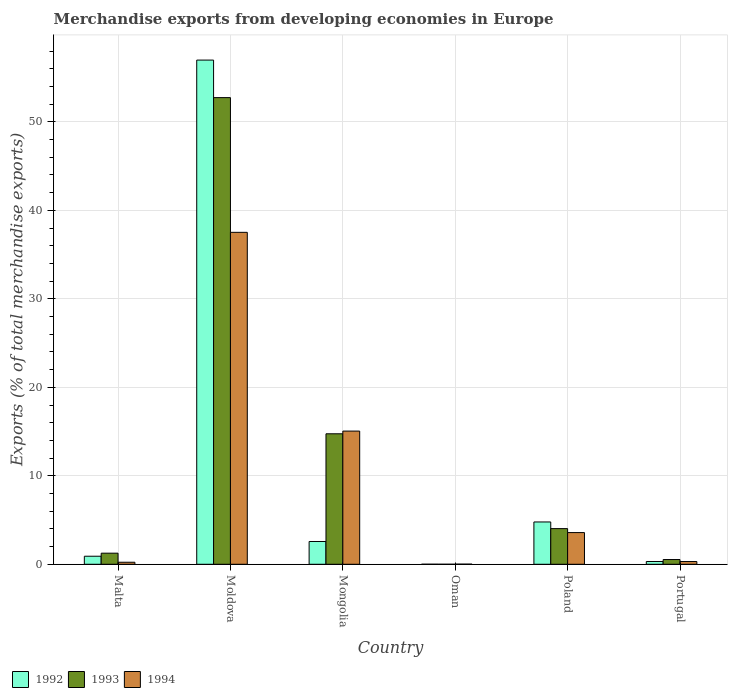How many different coloured bars are there?
Your answer should be compact. 3. How many groups of bars are there?
Provide a succinct answer. 6. How many bars are there on the 2nd tick from the left?
Provide a short and direct response. 3. What is the label of the 4th group of bars from the left?
Your response must be concise. Oman. In how many cases, is the number of bars for a given country not equal to the number of legend labels?
Provide a short and direct response. 0. What is the percentage of total merchandise exports in 1994 in Malta?
Keep it short and to the point. 0.23. Across all countries, what is the maximum percentage of total merchandise exports in 1992?
Give a very brief answer. 56.98. Across all countries, what is the minimum percentage of total merchandise exports in 1994?
Your answer should be very brief. 0.01. In which country was the percentage of total merchandise exports in 1992 maximum?
Your answer should be compact. Moldova. In which country was the percentage of total merchandise exports in 1993 minimum?
Your answer should be very brief. Oman. What is the total percentage of total merchandise exports in 1994 in the graph?
Your answer should be very brief. 56.7. What is the difference between the percentage of total merchandise exports in 1994 in Malta and that in Poland?
Your answer should be very brief. -3.35. What is the difference between the percentage of total merchandise exports in 1992 in Poland and the percentage of total merchandise exports in 1994 in Mongolia?
Make the answer very short. -10.27. What is the average percentage of total merchandise exports in 1993 per country?
Your answer should be very brief. 12.22. What is the difference between the percentage of total merchandise exports of/in 1993 and percentage of total merchandise exports of/in 1994 in Moldova?
Your answer should be compact. 15.22. What is the ratio of the percentage of total merchandise exports in 1994 in Malta to that in Moldova?
Ensure brevity in your answer.  0.01. Is the percentage of total merchandise exports in 1994 in Moldova less than that in Poland?
Provide a succinct answer. No. Is the difference between the percentage of total merchandise exports in 1993 in Malta and Moldova greater than the difference between the percentage of total merchandise exports in 1994 in Malta and Moldova?
Your answer should be very brief. No. What is the difference between the highest and the second highest percentage of total merchandise exports in 1994?
Your answer should be compact. -33.93. What is the difference between the highest and the lowest percentage of total merchandise exports in 1992?
Offer a very short reply. 56.97. In how many countries, is the percentage of total merchandise exports in 1993 greater than the average percentage of total merchandise exports in 1993 taken over all countries?
Make the answer very short. 2. Is the sum of the percentage of total merchandise exports in 1994 in Moldova and Poland greater than the maximum percentage of total merchandise exports in 1992 across all countries?
Provide a succinct answer. No. What does the 2nd bar from the left in Malta represents?
Provide a short and direct response. 1993. What does the 2nd bar from the right in Moldova represents?
Make the answer very short. 1993. How many bars are there?
Your answer should be compact. 18. Are all the bars in the graph horizontal?
Keep it short and to the point. No. How many countries are there in the graph?
Make the answer very short. 6. What is the difference between two consecutive major ticks on the Y-axis?
Offer a very short reply. 10. Does the graph contain grids?
Give a very brief answer. Yes. Where does the legend appear in the graph?
Make the answer very short. Bottom left. What is the title of the graph?
Your response must be concise. Merchandise exports from developing economies in Europe. What is the label or title of the X-axis?
Provide a short and direct response. Country. What is the label or title of the Y-axis?
Your answer should be very brief. Exports (% of total merchandise exports). What is the Exports (% of total merchandise exports) of 1992 in Malta?
Your response must be concise. 0.91. What is the Exports (% of total merchandise exports) of 1993 in Malta?
Your response must be concise. 1.26. What is the Exports (% of total merchandise exports) of 1994 in Malta?
Your answer should be very brief. 0.23. What is the Exports (% of total merchandise exports) in 1992 in Moldova?
Your answer should be very brief. 56.98. What is the Exports (% of total merchandise exports) of 1993 in Moldova?
Your response must be concise. 52.74. What is the Exports (% of total merchandise exports) of 1994 in Moldova?
Provide a succinct answer. 37.51. What is the Exports (% of total merchandise exports) in 1992 in Mongolia?
Ensure brevity in your answer.  2.57. What is the Exports (% of total merchandise exports) in 1993 in Mongolia?
Offer a very short reply. 14.75. What is the Exports (% of total merchandise exports) in 1994 in Mongolia?
Provide a succinct answer. 15.05. What is the Exports (% of total merchandise exports) of 1992 in Oman?
Your answer should be very brief. 0. What is the Exports (% of total merchandise exports) in 1993 in Oman?
Offer a terse response. 0. What is the Exports (% of total merchandise exports) in 1994 in Oman?
Your answer should be compact. 0.01. What is the Exports (% of total merchandise exports) of 1992 in Poland?
Ensure brevity in your answer.  4.78. What is the Exports (% of total merchandise exports) in 1993 in Poland?
Your answer should be compact. 4.03. What is the Exports (% of total merchandise exports) in 1994 in Poland?
Provide a succinct answer. 3.58. What is the Exports (% of total merchandise exports) in 1992 in Portugal?
Give a very brief answer. 0.32. What is the Exports (% of total merchandise exports) in 1993 in Portugal?
Offer a terse response. 0.54. What is the Exports (% of total merchandise exports) in 1994 in Portugal?
Provide a succinct answer. 0.31. Across all countries, what is the maximum Exports (% of total merchandise exports) in 1992?
Offer a terse response. 56.98. Across all countries, what is the maximum Exports (% of total merchandise exports) in 1993?
Make the answer very short. 52.74. Across all countries, what is the maximum Exports (% of total merchandise exports) of 1994?
Your answer should be very brief. 37.51. Across all countries, what is the minimum Exports (% of total merchandise exports) of 1992?
Offer a very short reply. 0. Across all countries, what is the minimum Exports (% of total merchandise exports) in 1993?
Provide a succinct answer. 0. Across all countries, what is the minimum Exports (% of total merchandise exports) in 1994?
Provide a short and direct response. 0.01. What is the total Exports (% of total merchandise exports) of 1992 in the graph?
Your answer should be compact. 65.56. What is the total Exports (% of total merchandise exports) of 1993 in the graph?
Provide a short and direct response. 73.31. What is the total Exports (% of total merchandise exports) in 1994 in the graph?
Offer a terse response. 56.7. What is the difference between the Exports (% of total merchandise exports) in 1992 in Malta and that in Moldova?
Your response must be concise. -56.07. What is the difference between the Exports (% of total merchandise exports) in 1993 in Malta and that in Moldova?
Ensure brevity in your answer.  -51.48. What is the difference between the Exports (% of total merchandise exports) in 1994 in Malta and that in Moldova?
Give a very brief answer. -37.28. What is the difference between the Exports (% of total merchandise exports) in 1992 in Malta and that in Mongolia?
Provide a succinct answer. -1.66. What is the difference between the Exports (% of total merchandise exports) in 1993 in Malta and that in Mongolia?
Ensure brevity in your answer.  -13.49. What is the difference between the Exports (% of total merchandise exports) in 1994 in Malta and that in Mongolia?
Your response must be concise. -14.82. What is the difference between the Exports (% of total merchandise exports) in 1992 in Malta and that in Oman?
Offer a terse response. 0.91. What is the difference between the Exports (% of total merchandise exports) of 1993 in Malta and that in Oman?
Offer a terse response. 1.25. What is the difference between the Exports (% of total merchandise exports) in 1994 in Malta and that in Oman?
Give a very brief answer. 0.22. What is the difference between the Exports (% of total merchandise exports) in 1992 in Malta and that in Poland?
Your answer should be compact. -3.87. What is the difference between the Exports (% of total merchandise exports) in 1993 in Malta and that in Poland?
Make the answer very short. -2.78. What is the difference between the Exports (% of total merchandise exports) in 1994 in Malta and that in Poland?
Make the answer very short. -3.35. What is the difference between the Exports (% of total merchandise exports) in 1992 in Malta and that in Portugal?
Make the answer very short. 0.6. What is the difference between the Exports (% of total merchandise exports) in 1993 in Malta and that in Portugal?
Your answer should be compact. 0.72. What is the difference between the Exports (% of total merchandise exports) of 1994 in Malta and that in Portugal?
Keep it short and to the point. -0.08. What is the difference between the Exports (% of total merchandise exports) of 1992 in Moldova and that in Mongolia?
Keep it short and to the point. 54.4. What is the difference between the Exports (% of total merchandise exports) of 1993 in Moldova and that in Mongolia?
Make the answer very short. 37.99. What is the difference between the Exports (% of total merchandise exports) of 1994 in Moldova and that in Mongolia?
Ensure brevity in your answer.  22.46. What is the difference between the Exports (% of total merchandise exports) in 1992 in Moldova and that in Oman?
Provide a short and direct response. 56.97. What is the difference between the Exports (% of total merchandise exports) of 1993 in Moldova and that in Oman?
Make the answer very short. 52.74. What is the difference between the Exports (% of total merchandise exports) in 1994 in Moldova and that in Oman?
Keep it short and to the point. 37.5. What is the difference between the Exports (% of total merchandise exports) of 1992 in Moldova and that in Poland?
Give a very brief answer. 52.2. What is the difference between the Exports (% of total merchandise exports) of 1993 in Moldova and that in Poland?
Give a very brief answer. 48.71. What is the difference between the Exports (% of total merchandise exports) of 1994 in Moldova and that in Poland?
Your response must be concise. 33.93. What is the difference between the Exports (% of total merchandise exports) of 1992 in Moldova and that in Portugal?
Offer a terse response. 56.66. What is the difference between the Exports (% of total merchandise exports) of 1993 in Moldova and that in Portugal?
Provide a succinct answer. 52.2. What is the difference between the Exports (% of total merchandise exports) of 1994 in Moldova and that in Portugal?
Give a very brief answer. 37.2. What is the difference between the Exports (% of total merchandise exports) in 1992 in Mongolia and that in Oman?
Your response must be concise. 2.57. What is the difference between the Exports (% of total merchandise exports) of 1993 in Mongolia and that in Oman?
Offer a very short reply. 14.75. What is the difference between the Exports (% of total merchandise exports) of 1994 in Mongolia and that in Oman?
Offer a terse response. 15.04. What is the difference between the Exports (% of total merchandise exports) of 1992 in Mongolia and that in Poland?
Provide a short and direct response. -2.21. What is the difference between the Exports (% of total merchandise exports) in 1993 in Mongolia and that in Poland?
Offer a very short reply. 10.72. What is the difference between the Exports (% of total merchandise exports) of 1994 in Mongolia and that in Poland?
Offer a terse response. 11.47. What is the difference between the Exports (% of total merchandise exports) of 1992 in Mongolia and that in Portugal?
Give a very brief answer. 2.26. What is the difference between the Exports (% of total merchandise exports) in 1993 in Mongolia and that in Portugal?
Provide a succinct answer. 14.21. What is the difference between the Exports (% of total merchandise exports) of 1994 in Mongolia and that in Portugal?
Offer a very short reply. 14.74. What is the difference between the Exports (% of total merchandise exports) of 1992 in Oman and that in Poland?
Offer a very short reply. -4.78. What is the difference between the Exports (% of total merchandise exports) of 1993 in Oman and that in Poland?
Offer a very short reply. -4.03. What is the difference between the Exports (% of total merchandise exports) in 1994 in Oman and that in Poland?
Your response must be concise. -3.57. What is the difference between the Exports (% of total merchandise exports) in 1992 in Oman and that in Portugal?
Ensure brevity in your answer.  -0.31. What is the difference between the Exports (% of total merchandise exports) of 1993 in Oman and that in Portugal?
Offer a terse response. -0.53. What is the difference between the Exports (% of total merchandise exports) of 1994 in Oman and that in Portugal?
Your answer should be very brief. -0.29. What is the difference between the Exports (% of total merchandise exports) of 1992 in Poland and that in Portugal?
Provide a short and direct response. 4.47. What is the difference between the Exports (% of total merchandise exports) in 1993 in Poland and that in Portugal?
Provide a short and direct response. 3.49. What is the difference between the Exports (% of total merchandise exports) in 1994 in Poland and that in Portugal?
Ensure brevity in your answer.  3.27. What is the difference between the Exports (% of total merchandise exports) in 1992 in Malta and the Exports (% of total merchandise exports) in 1993 in Moldova?
Provide a short and direct response. -51.83. What is the difference between the Exports (% of total merchandise exports) in 1992 in Malta and the Exports (% of total merchandise exports) in 1994 in Moldova?
Provide a succinct answer. -36.6. What is the difference between the Exports (% of total merchandise exports) of 1993 in Malta and the Exports (% of total merchandise exports) of 1994 in Moldova?
Give a very brief answer. -36.26. What is the difference between the Exports (% of total merchandise exports) in 1992 in Malta and the Exports (% of total merchandise exports) in 1993 in Mongolia?
Keep it short and to the point. -13.84. What is the difference between the Exports (% of total merchandise exports) in 1992 in Malta and the Exports (% of total merchandise exports) in 1994 in Mongolia?
Your answer should be compact. -14.14. What is the difference between the Exports (% of total merchandise exports) of 1993 in Malta and the Exports (% of total merchandise exports) of 1994 in Mongolia?
Ensure brevity in your answer.  -13.8. What is the difference between the Exports (% of total merchandise exports) of 1992 in Malta and the Exports (% of total merchandise exports) of 1993 in Oman?
Give a very brief answer. 0.91. What is the difference between the Exports (% of total merchandise exports) of 1992 in Malta and the Exports (% of total merchandise exports) of 1994 in Oman?
Make the answer very short. 0.9. What is the difference between the Exports (% of total merchandise exports) in 1993 in Malta and the Exports (% of total merchandise exports) in 1994 in Oman?
Your response must be concise. 1.24. What is the difference between the Exports (% of total merchandise exports) in 1992 in Malta and the Exports (% of total merchandise exports) in 1993 in Poland?
Give a very brief answer. -3.12. What is the difference between the Exports (% of total merchandise exports) of 1992 in Malta and the Exports (% of total merchandise exports) of 1994 in Poland?
Ensure brevity in your answer.  -2.67. What is the difference between the Exports (% of total merchandise exports) of 1993 in Malta and the Exports (% of total merchandise exports) of 1994 in Poland?
Your answer should be very brief. -2.33. What is the difference between the Exports (% of total merchandise exports) of 1992 in Malta and the Exports (% of total merchandise exports) of 1993 in Portugal?
Provide a succinct answer. 0.37. What is the difference between the Exports (% of total merchandise exports) of 1992 in Malta and the Exports (% of total merchandise exports) of 1994 in Portugal?
Offer a terse response. 0.6. What is the difference between the Exports (% of total merchandise exports) in 1993 in Malta and the Exports (% of total merchandise exports) in 1994 in Portugal?
Offer a very short reply. 0.95. What is the difference between the Exports (% of total merchandise exports) in 1992 in Moldova and the Exports (% of total merchandise exports) in 1993 in Mongolia?
Offer a terse response. 42.23. What is the difference between the Exports (% of total merchandise exports) in 1992 in Moldova and the Exports (% of total merchandise exports) in 1994 in Mongolia?
Give a very brief answer. 41.93. What is the difference between the Exports (% of total merchandise exports) in 1993 in Moldova and the Exports (% of total merchandise exports) in 1994 in Mongolia?
Give a very brief answer. 37.69. What is the difference between the Exports (% of total merchandise exports) in 1992 in Moldova and the Exports (% of total merchandise exports) in 1993 in Oman?
Keep it short and to the point. 56.98. What is the difference between the Exports (% of total merchandise exports) of 1992 in Moldova and the Exports (% of total merchandise exports) of 1994 in Oman?
Your response must be concise. 56.96. What is the difference between the Exports (% of total merchandise exports) in 1993 in Moldova and the Exports (% of total merchandise exports) in 1994 in Oman?
Offer a very short reply. 52.72. What is the difference between the Exports (% of total merchandise exports) of 1992 in Moldova and the Exports (% of total merchandise exports) of 1993 in Poland?
Your answer should be compact. 52.95. What is the difference between the Exports (% of total merchandise exports) in 1992 in Moldova and the Exports (% of total merchandise exports) in 1994 in Poland?
Ensure brevity in your answer.  53.4. What is the difference between the Exports (% of total merchandise exports) of 1993 in Moldova and the Exports (% of total merchandise exports) of 1994 in Poland?
Your response must be concise. 49.15. What is the difference between the Exports (% of total merchandise exports) of 1992 in Moldova and the Exports (% of total merchandise exports) of 1993 in Portugal?
Make the answer very short. 56.44. What is the difference between the Exports (% of total merchandise exports) in 1992 in Moldova and the Exports (% of total merchandise exports) in 1994 in Portugal?
Your answer should be compact. 56.67. What is the difference between the Exports (% of total merchandise exports) of 1993 in Moldova and the Exports (% of total merchandise exports) of 1994 in Portugal?
Offer a terse response. 52.43. What is the difference between the Exports (% of total merchandise exports) in 1992 in Mongolia and the Exports (% of total merchandise exports) in 1993 in Oman?
Give a very brief answer. 2.57. What is the difference between the Exports (% of total merchandise exports) of 1992 in Mongolia and the Exports (% of total merchandise exports) of 1994 in Oman?
Make the answer very short. 2.56. What is the difference between the Exports (% of total merchandise exports) in 1993 in Mongolia and the Exports (% of total merchandise exports) in 1994 in Oman?
Provide a short and direct response. 14.73. What is the difference between the Exports (% of total merchandise exports) in 1992 in Mongolia and the Exports (% of total merchandise exports) in 1993 in Poland?
Give a very brief answer. -1.46. What is the difference between the Exports (% of total merchandise exports) in 1992 in Mongolia and the Exports (% of total merchandise exports) in 1994 in Poland?
Offer a very short reply. -1.01. What is the difference between the Exports (% of total merchandise exports) in 1993 in Mongolia and the Exports (% of total merchandise exports) in 1994 in Poland?
Make the answer very short. 11.16. What is the difference between the Exports (% of total merchandise exports) in 1992 in Mongolia and the Exports (% of total merchandise exports) in 1993 in Portugal?
Provide a short and direct response. 2.04. What is the difference between the Exports (% of total merchandise exports) of 1992 in Mongolia and the Exports (% of total merchandise exports) of 1994 in Portugal?
Ensure brevity in your answer.  2.27. What is the difference between the Exports (% of total merchandise exports) in 1993 in Mongolia and the Exports (% of total merchandise exports) in 1994 in Portugal?
Offer a very short reply. 14.44. What is the difference between the Exports (% of total merchandise exports) of 1992 in Oman and the Exports (% of total merchandise exports) of 1993 in Poland?
Your answer should be very brief. -4.03. What is the difference between the Exports (% of total merchandise exports) in 1992 in Oman and the Exports (% of total merchandise exports) in 1994 in Poland?
Give a very brief answer. -3.58. What is the difference between the Exports (% of total merchandise exports) of 1993 in Oman and the Exports (% of total merchandise exports) of 1994 in Poland?
Your answer should be compact. -3.58. What is the difference between the Exports (% of total merchandise exports) in 1992 in Oman and the Exports (% of total merchandise exports) in 1993 in Portugal?
Give a very brief answer. -0.53. What is the difference between the Exports (% of total merchandise exports) of 1992 in Oman and the Exports (% of total merchandise exports) of 1994 in Portugal?
Provide a short and direct response. -0.3. What is the difference between the Exports (% of total merchandise exports) of 1993 in Oman and the Exports (% of total merchandise exports) of 1994 in Portugal?
Keep it short and to the point. -0.31. What is the difference between the Exports (% of total merchandise exports) in 1992 in Poland and the Exports (% of total merchandise exports) in 1993 in Portugal?
Offer a very short reply. 4.25. What is the difference between the Exports (% of total merchandise exports) of 1992 in Poland and the Exports (% of total merchandise exports) of 1994 in Portugal?
Provide a succinct answer. 4.47. What is the difference between the Exports (% of total merchandise exports) of 1993 in Poland and the Exports (% of total merchandise exports) of 1994 in Portugal?
Provide a succinct answer. 3.72. What is the average Exports (% of total merchandise exports) of 1992 per country?
Make the answer very short. 10.93. What is the average Exports (% of total merchandise exports) of 1993 per country?
Your answer should be compact. 12.22. What is the average Exports (% of total merchandise exports) in 1994 per country?
Keep it short and to the point. 9.45. What is the difference between the Exports (% of total merchandise exports) of 1992 and Exports (% of total merchandise exports) of 1993 in Malta?
Your answer should be very brief. -0.34. What is the difference between the Exports (% of total merchandise exports) of 1992 and Exports (% of total merchandise exports) of 1994 in Malta?
Keep it short and to the point. 0.68. What is the difference between the Exports (% of total merchandise exports) in 1993 and Exports (% of total merchandise exports) in 1994 in Malta?
Your answer should be very brief. 1.03. What is the difference between the Exports (% of total merchandise exports) of 1992 and Exports (% of total merchandise exports) of 1993 in Moldova?
Give a very brief answer. 4.24. What is the difference between the Exports (% of total merchandise exports) in 1992 and Exports (% of total merchandise exports) in 1994 in Moldova?
Provide a succinct answer. 19.47. What is the difference between the Exports (% of total merchandise exports) in 1993 and Exports (% of total merchandise exports) in 1994 in Moldova?
Provide a succinct answer. 15.22. What is the difference between the Exports (% of total merchandise exports) in 1992 and Exports (% of total merchandise exports) in 1993 in Mongolia?
Provide a short and direct response. -12.17. What is the difference between the Exports (% of total merchandise exports) of 1992 and Exports (% of total merchandise exports) of 1994 in Mongolia?
Provide a short and direct response. -12.48. What is the difference between the Exports (% of total merchandise exports) of 1993 and Exports (% of total merchandise exports) of 1994 in Mongolia?
Give a very brief answer. -0.31. What is the difference between the Exports (% of total merchandise exports) in 1992 and Exports (% of total merchandise exports) in 1993 in Oman?
Provide a short and direct response. 0. What is the difference between the Exports (% of total merchandise exports) in 1992 and Exports (% of total merchandise exports) in 1994 in Oman?
Your answer should be very brief. -0.01. What is the difference between the Exports (% of total merchandise exports) in 1993 and Exports (% of total merchandise exports) in 1994 in Oman?
Ensure brevity in your answer.  -0.01. What is the difference between the Exports (% of total merchandise exports) in 1992 and Exports (% of total merchandise exports) in 1993 in Poland?
Your answer should be very brief. 0.75. What is the difference between the Exports (% of total merchandise exports) in 1992 and Exports (% of total merchandise exports) in 1994 in Poland?
Your response must be concise. 1.2. What is the difference between the Exports (% of total merchandise exports) in 1993 and Exports (% of total merchandise exports) in 1994 in Poland?
Your answer should be compact. 0.45. What is the difference between the Exports (% of total merchandise exports) of 1992 and Exports (% of total merchandise exports) of 1993 in Portugal?
Your answer should be very brief. -0.22. What is the difference between the Exports (% of total merchandise exports) of 1992 and Exports (% of total merchandise exports) of 1994 in Portugal?
Make the answer very short. 0.01. What is the difference between the Exports (% of total merchandise exports) of 1993 and Exports (% of total merchandise exports) of 1994 in Portugal?
Your response must be concise. 0.23. What is the ratio of the Exports (% of total merchandise exports) of 1992 in Malta to that in Moldova?
Offer a terse response. 0.02. What is the ratio of the Exports (% of total merchandise exports) of 1993 in Malta to that in Moldova?
Your answer should be compact. 0.02. What is the ratio of the Exports (% of total merchandise exports) of 1994 in Malta to that in Moldova?
Your response must be concise. 0.01. What is the ratio of the Exports (% of total merchandise exports) in 1992 in Malta to that in Mongolia?
Make the answer very short. 0.35. What is the ratio of the Exports (% of total merchandise exports) of 1993 in Malta to that in Mongolia?
Make the answer very short. 0.09. What is the ratio of the Exports (% of total merchandise exports) of 1994 in Malta to that in Mongolia?
Give a very brief answer. 0.02. What is the ratio of the Exports (% of total merchandise exports) in 1992 in Malta to that in Oman?
Your response must be concise. 217.68. What is the ratio of the Exports (% of total merchandise exports) in 1993 in Malta to that in Oman?
Provide a succinct answer. 844.69. What is the ratio of the Exports (% of total merchandise exports) of 1994 in Malta to that in Oman?
Offer a very short reply. 16.11. What is the ratio of the Exports (% of total merchandise exports) of 1992 in Malta to that in Poland?
Provide a succinct answer. 0.19. What is the ratio of the Exports (% of total merchandise exports) of 1993 in Malta to that in Poland?
Provide a succinct answer. 0.31. What is the ratio of the Exports (% of total merchandise exports) of 1994 in Malta to that in Poland?
Offer a terse response. 0.06. What is the ratio of the Exports (% of total merchandise exports) of 1992 in Malta to that in Portugal?
Your answer should be compact. 2.89. What is the ratio of the Exports (% of total merchandise exports) in 1993 in Malta to that in Portugal?
Ensure brevity in your answer.  2.34. What is the ratio of the Exports (% of total merchandise exports) in 1994 in Malta to that in Portugal?
Keep it short and to the point. 0.74. What is the ratio of the Exports (% of total merchandise exports) in 1992 in Moldova to that in Mongolia?
Give a very brief answer. 22.13. What is the ratio of the Exports (% of total merchandise exports) of 1993 in Moldova to that in Mongolia?
Provide a short and direct response. 3.58. What is the ratio of the Exports (% of total merchandise exports) of 1994 in Moldova to that in Mongolia?
Your answer should be very brief. 2.49. What is the ratio of the Exports (% of total merchandise exports) of 1992 in Moldova to that in Oman?
Your response must be concise. 1.36e+04. What is the ratio of the Exports (% of total merchandise exports) in 1993 in Moldova to that in Oman?
Your answer should be very brief. 3.55e+04. What is the ratio of the Exports (% of total merchandise exports) of 1994 in Moldova to that in Oman?
Your answer should be very brief. 2631.64. What is the ratio of the Exports (% of total merchandise exports) of 1992 in Moldova to that in Poland?
Keep it short and to the point. 11.92. What is the ratio of the Exports (% of total merchandise exports) of 1993 in Moldova to that in Poland?
Provide a short and direct response. 13.08. What is the ratio of the Exports (% of total merchandise exports) in 1994 in Moldova to that in Poland?
Offer a very short reply. 10.47. What is the ratio of the Exports (% of total merchandise exports) of 1992 in Moldova to that in Portugal?
Your answer should be compact. 180.84. What is the ratio of the Exports (% of total merchandise exports) in 1993 in Moldova to that in Portugal?
Offer a very short reply. 98.37. What is the ratio of the Exports (% of total merchandise exports) of 1994 in Moldova to that in Portugal?
Make the answer very short. 121.39. What is the ratio of the Exports (% of total merchandise exports) of 1992 in Mongolia to that in Oman?
Ensure brevity in your answer.  615.69. What is the ratio of the Exports (% of total merchandise exports) of 1993 in Mongolia to that in Oman?
Provide a short and direct response. 9923.6. What is the ratio of the Exports (% of total merchandise exports) of 1994 in Mongolia to that in Oman?
Ensure brevity in your answer.  1055.93. What is the ratio of the Exports (% of total merchandise exports) in 1992 in Mongolia to that in Poland?
Your answer should be very brief. 0.54. What is the ratio of the Exports (% of total merchandise exports) in 1993 in Mongolia to that in Poland?
Your answer should be compact. 3.66. What is the ratio of the Exports (% of total merchandise exports) in 1994 in Mongolia to that in Poland?
Offer a very short reply. 4.2. What is the ratio of the Exports (% of total merchandise exports) of 1992 in Mongolia to that in Portugal?
Offer a very short reply. 8.17. What is the ratio of the Exports (% of total merchandise exports) in 1993 in Mongolia to that in Portugal?
Your response must be concise. 27.51. What is the ratio of the Exports (% of total merchandise exports) in 1994 in Mongolia to that in Portugal?
Keep it short and to the point. 48.71. What is the ratio of the Exports (% of total merchandise exports) in 1992 in Oman to that in Poland?
Give a very brief answer. 0. What is the ratio of the Exports (% of total merchandise exports) of 1994 in Oman to that in Poland?
Keep it short and to the point. 0. What is the ratio of the Exports (% of total merchandise exports) of 1992 in Oman to that in Portugal?
Your answer should be very brief. 0.01. What is the ratio of the Exports (% of total merchandise exports) of 1993 in Oman to that in Portugal?
Offer a terse response. 0. What is the ratio of the Exports (% of total merchandise exports) of 1994 in Oman to that in Portugal?
Offer a very short reply. 0.05. What is the ratio of the Exports (% of total merchandise exports) of 1992 in Poland to that in Portugal?
Offer a very short reply. 15.18. What is the ratio of the Exports (% of total merchandise exports) of 1993 in Poland to that in Portugal?
Your answer should be compact. 7.52. What is the ratio of the Exports (% of total merchandise exports) of 1994 in Poland to that in Portugal?
Offer a very short reply. 11.59. What is the difference between the highest and the second highest Exports (% of total merchandise exports) of 1992?
Give a very brief answer. 52.2. What is the difference between the highest and the second highest Exports (% of total merchandise exports) in 1993?
Keep it short and to the point. 37.99. What is the difference between the highest and the second highest Exports (% of total merchandise exports) in 1994?
Provide a succinct answer. 22.46. What is the difference between the highest and the lowest Exports (% of total merchandise exports) in 1992?
Provide a succinct answer. 56.97. What is the difference between the highest and the lowest Exports (% of total merchandise exports) of 1993?
Your answer should be compact. 52.74. What is the difference between the highest and the lowest Exports (% of total merchandise exports) of 1994?
Make the answer very short. 37.5. 